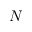Convert formula to latex. <formula><loc_0><loc_0><loc_500><loc_500>N</formula> 